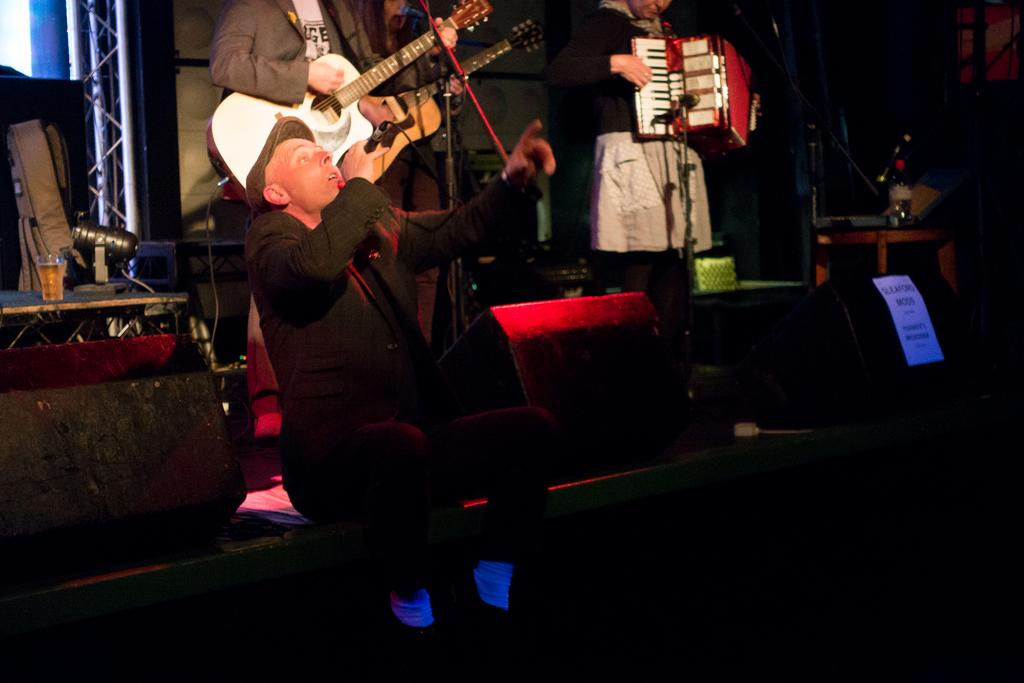Who is the main subject in the image? There is a man in the image. What is the man holding in his right hand? The man is holding a microphone in his right hand. What is the man doing in the image? The man is singing. Can you describe the background of the image? There is a guitar player in the background of the image. What type of baseball equipment can be seen in the image? There is no baseball equipment present in the image. What kind of paper is the man reading from while singing? The man is not reading from any paper while singing; he is holding a microphone. 